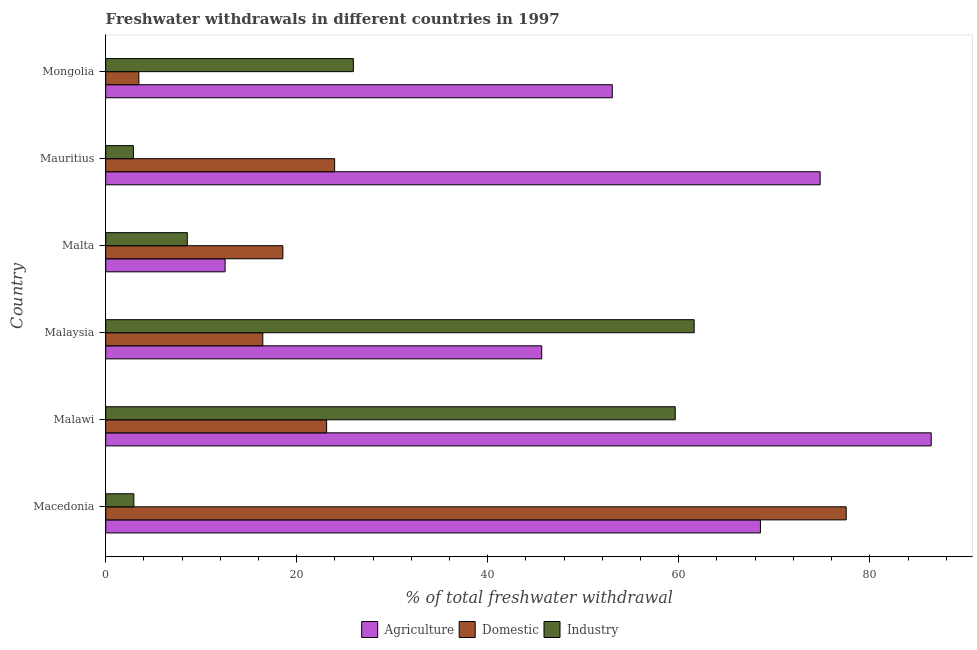Are the number of bars per tick equal to the number of legend labels?
Make the answer very short. Yes. Are the number of bars on each tick of the Y-axis equal?
Ensure brevity in your answer.  Yes. What is the label of the 3rd group of bars from the top?
Make the answer very short. Malta. In how many cases, is the number of bars for a given country not equal to the number of legend labels?
Give a very brief answer. 0. What is the percentage of freshwater withdrawal for agriculture in Mauritius?
Keep it short and to the point. 74.8. Across all countries, what is the maximum percentage of freshwater withdrawal for agriculture?
Offer a terse response. 86.43. Across all countries, what is the minimum percentage of freshwater withdrawal for domestic purposes?
Provide a succinct answer. 3.47. In which country was the percentage of freshwater withdrawal for agriculture maximum?
Offer a terse response. Malawi. In which country was the percentage of freshwater withdrawal for agriculture minimum?
Provide a short and direct response. Malta. What is the total percentage of freshwater withdrawal for domestic purposes in the graph?
Your answer should be compact. 163.1. What is the difference between the percentage of freshwater withdrawal for industry in Malta and that in Mongolia?
Offer a very short reply. -17.39. What is the difference between the percentage of freshwater withdrawal for agriculture in Malaysia and the percentage of freshwater withdrawal for industry in Mauritius?
Provide a short and direct response. 42.75. What is the average percentage of freshwater withdrawal for agriculture per country?
Ensure brevity in your answer.  56.83. What is the difference between the percentage of freshwater withdrawal for industry and percentage of freshwater withdrawal for agriculture in Mongolia?
Your response must be concise. -27.11. What is the ratio of the percentage of freshwater withdrawal for agriculture in Malawi to that in Malta?
Ensure brevity in your answer.  6.91. Is the percentage of freshwater withdrawal for domestic purposes in Malaysia less than that in Mauritius?
Offer a very short reply. Yes. What is the difference between the highest and the second highest percentage of freshwater withdrawal for agriculture?
Your response must be concise. 11.63. What is the difference between the highest and the lowest percentage of freshwater withdrawal for domestic purposes?
Provide a short and direct response. 74.06. In how many countries, is the percentage of freshwater withdrawal for industry greater than the average percentage of freshwater withdrawal for industry taken over all countries?
Give a very brief answer. 2. Is the sum of the percentage of freshwater withdrawal for agriculture in Macedonia and Mauritius greater than the maximum percentage of freshwater withdrawal for domestic purposes across all countries?
Ensure brevity in your answer.  Yes. What does the 1st bar from the top in Malaysia represents?
Provide a succinct answer. Industry. What does the 2nd bar from the bottom in Macedonia represents?
Provide a short and direct response. Domestic. How many bars are there?
Your answer should be very brief. 18. Are all the bars in the graph horizontal?
Your answer should be very brief. Yes. Are the values on the major ticks of X-axis written in scientific E-notation?
Give a very brief answer. No. Does the graph contain any zero values?
Your answer should be compact. No. Does the graph contain grids?
Provide a succinct answer. No. What is the title of the graph?
Your answer should be compact. Freshwater withdrawals in different countries in 1997. What is the label or title of the X-axis?
Ensure brevity in your answer.  % of total freshwater withdrawal. What is the label or title of the Y-axis?
Provide a succinct answer. Country. What is the % of total freshwater withdrawal in Agriculture in Macedonia?
Ensure brevity in your answer.  68.55. What is the % of total freshwater withdrawal in Domestic in Macedonia?
Give a very brief answer. 77.53. What is the % of total freshwater withdrawal in Industry in Macedonia?
Provide a succinct answer. 2.95. What is the % of total freshwater withdrawal in Agriculture in Malawi?
Your response must be concise. 86.43. What is the % of total freshwater withdrawal of Domestic in Malawi?
Ensure brevity in your answer.  23.13. What is the % of total freshwater withdrawal of Industry in Malawi?
Provide a short and direct response. 59.63. What is the % of total freshwater withdrawal of Agriculture in Malaysia?
Make the answer very short. 45.65. What is the % of total freshwater withdrawal in Domestic in Malaysia?
Your response must be concise. 16.45. What is the % of total freshwater withdrawal in Industry in Malaysia?
Ensure brevity in your answer.  61.61. What is the % of total freshwater withdrawal in Agriculture in Malta?
Your answer should be compact. 12.5. What is the % of total freshwater withdrawal in Domestic in Malta?
Keep it short and to the point. 18.55. What is the % of total freshwater withdrawal of Industry in Malta?
Your response must be concise. 8.54. What is the % of total freshwater withdrawal of Agriculture in Mauritius?
Offer a terse response. 74.8. What is the % of total freshwater withdrawal of Domestic in Mauritius?
Your answer should be very brief. 23.97. What is the % of total freshwater withdrawal of Industry in Mauritius?
Offer a terse response. 2.9. What is the % of total freshwater withdrawal of Agriculture in Mongolia?
Your answer should be very brief. 53.04. What is the % of total freshwater withdrawal in Domestic in Mongolia?
Offer a very short reply. 3.47. What is the % of total freshwater withdrawal of Industry in Mongolia?
Provide a succinct answer. 25.93. Across all countries, what is the maximum % of total freshwater withdrawal in Agriculture?
Your answer should be very brief. 86.43. Across all countries, what is the maximum % of total freshwater withdrawal in Domestic?
Give a very brief answer. 77.53. Across all countries, what is the maximum % of total freshwater withdrawal in Industry?
Give a very brief answer. 61.61. Across all countries, what is the minimum % of total freshwater withdrawal in Agriculture?
Offer a terse response. 12.5. Across all countries, what is the minimum % of total freshwater withdrawal of Domestic?
Keep it short and to the point. 3.47. Across all countries, what is the minimum % of total freshwater withdrawal of Industry?
Keep it short and to the point. 2.9. What is the total % of total freshwater withdrawal in Agriculture in the graph?
Give a very brief answer. 340.97. What is the total % of total freshwater withdrawal of Domestic in the graph?
Offer a very short reply. 163.1. What is the total % of total freshwater withdrawal in Industry in the graph?
Your answer should be compact. 161.56. What is the difference between the % of total freshwater withdrawal in Agriculture in Macedonia and that in Malawi?
Make the answer very short. -17.88. What is the difference between the % of total freshwater withdrawal in Domestic in Macedonia and that in Malawi?
Offer a very short reply. 54.4. What is the difference between the % of total freshwater withdrawal in Industry in Macedonia and that in Malawi?
Your response must be concise. -56.68. What is the difference between the % of total freshwater withdrawal in Agriculture in Macedonia and that in Malaysia?
Ensure brevity in your answer.  22.9. What is the difference between the % of total freshwater withdrawal of Domestic in Macedonia and that in Malaysia?
Provide a short and direct response. 61.08. What is the difference between the % of total freshwater withdrawal in Industry in Macedonia and that in Malaysia?
Provide a short and direct response. -58.66. What is the difference between the % of total freshwater withdrawal in Agriculture in Macedonia and that in Malta?
Offer a very short reply. 56.05. What is the difference between the % of total freshwater withdrawal of Domestic in Macedonia and that in Malta?
Give a very brief answer. 58.98. What is the difference between the % of total freshwater withdrawal of Industry in Macedonia and that in Malta?
Keep it short and to the point. -5.59. What is the difference between the % of total freshwater withdrawal of Agriculture in Macedonia and that in Mauritius?
Keep it short and to the point. -6.25. What is the difference between the % of total freshwater withdrawal in Domestic in Macedonia and that in Mauritius?
Ensure brevity in your answer.  53.56. What is the difference between the % of total freshwater withdrawal in Industry in Macedonia and that in Mauritius?
Ensure brevity in your answer.  0.05. What is the difference between the % of total freshwater withdrawal in Agriculture in Macedonia and that in Mongolia?
Your answer should be very brief. 15.51. What is the difference between the % of total freshwater withdrawal of Domestic in Macedonia and that in Mongolia?
Make the answer very short. 74.06. What is the difference between the % of total freshwater withdrawal in Industry in Macedonia and that in Mongolia?
Offer a very short reply. -22.98. What is the difference between the % of total freshwater withdrawal in Agriculture in Malawi and that in Malaysia?
Offer a very short reply. 40.78. What is the difference between the % of total freshwater withdrawal in Domestic in Malawi and that in Malaysia?
Provide a short and direct response. 6.68. What is the difference between the % of total freshwater withdrawal of Industry in Malawi and that in Malaysia?
Your answer should be very brief. -1.98. What is the difference between the % of total freshwater withdrawal of Agriculture in Malawi and that in Malta?
Offer a very short reply. 73.93. What is the difference between the % of total freshwater withdrawal of Domestic in Malawi and that in Malta?
Offer a terse response. 4.58. What is the difference between the % of total freshwater withdrawal in Industry in Malawi and that in Malta?
Provide a succinct answer. 51.09. What is the difference between the % of total freshwater withdrawal of Agriculture in Malawi and that in Mauritius?
Provide a succinct answer. 11.63. What is the difference between the % of total freshwater withdrawal in Domestic in Malawi and that in Mauritius?
Offer a very short reply. -0.84. What is the difference between the % of total freshwater withdrawal in Industry in Malawi and that in Mauritius?
Offer a terse response. 56.73. What is the difference between the % of total freshwater withdrawal in Agriculture in Malawi and that in Mongolia?
Provide a short and direct response. 33.39. What is the difference between the % of total freshwater withdrawal in Domestic in Malawi and that in Mongolia?
Your answer should be compact. 19.66. What is the difference between the % of total freshwater withdrawal in Industry in Malawi and that in Mongolia?
Your answer should be very brief. 33.7. What is the difference between the % of total freshwater withdrawal in Agriculture in Malaysia and that in Malta?
Your answer should be very brief. 33.15. What is the difference between the % of total freshwater withdrawal in Industry in Malaysia and that in Malta?
Offer a terse response. 53.07. What is the difference between the % of total freshwater withdrawal in Agriculture in Malaysia and that in Mauritius?
Your response must be concise. -29.15. What is the difference between the % of total freshwater withdrawal in Domestic in Malaysia and that in Mauritius?
Provide a succinct answer. -7.52. What is the difference between the % of total freshwater withdrawal in Industry in Malaysia and that in Mauritius?
Ensure brevity in your answer.  58.71. What is the difference between the % of total freshwater withdrawal in Agriculture in Malaysia and that in Mongolia?
Keep it short and to the point. -7.39. What is the difference between the % of total freshwater withdrawal of Domestic in Malaysia and that in Mongolia?
Offer a very short reply. 12.98. What is the difference between the % of total freshwater withdrawal of Industry in Malaysia and that in Mongolia?
Ensure brevity in your answer.  35.68. What is the difference between the % of total freshwater withdrawal of Agriculture in Malta and that in Mauritius?
Make the answer very short. -62.3. What is the difference between the % of total freshwater withdrawal of Domestic in Malta and that in Mauritius?
Provide a succinct answer. -5.42. What is the difference between the % of total freshwater withdrawal of Industry in Malta and that in Mauritius?
Provide a succinct answer. 5.65. What is the difference between the % of total freshwater withdrawal in Agriculture in Malta and that in Mongolia?
Make the answer very short. -40.54. What is the difference between the % of total freshwater withdrawal of Domestic in Malta and that in Mongolia?
Keep it short and to the point. 15.08. What is the difference between the % of total freshwater withdrawal in Industry in Malta and that in Mongolia?
Make the answer very short. -17.39. What is the difference between the % of total freshwater withdrawal in Agriculture in Mauritius and that in Mongolia?
Your answer should be very brief. 21.76. What is the difference between the % of total freshwater withdrawal in Domestic in Mauritius and that in Mongolia?
Offer a terse response. 20.5. What is the difference between the % of total freshwater withdrawal of Industry in Mauritius and that in Mongolia?
Your response must be concise. -23.03. What is the difference between the % of total freshwater withdrawal in Agriculture in Macedonia and the % of total freshwater withdrawal in Domestic in Malawi?
Make the answer very short. 45.42. What is the difference between the % of total freshwater withdrawal in Agriculture in Macedonia and the % of total freshwater withdrawal in Industry in Malawi?
Ensure brevity in your answer.  8.92. What is the difference between the % of total freshwater withdrawal of Agriculture in Macedonia and the % of total freshwater withdrawal of Domestic in Malaysia?
Your answer should be very brief. 52.1. What is the difference between the % of total freshwater withdrawal of Agriculture in Macedonia and the % of total freshwater withdrawal of Industry in Malaysia?
Offer a very short reply. 6.94. What is the difference between the % of total freshwater withdrawal of Domestic in Macedonia and the % of total freshwater withdrawal of Industry in Malaysia?
Offer a very short reply. 15.92. What is the difference between the % of total freshwater withdrawal in Agriculture in Macedonia and the % of total freshwater withdrawal in Industry in Malta?
Ensure brevity in your answer.  60.01. What is the difference between the % of total freshwater withdrawal in Domestic in Macedonia and the % of total freshwater withdrawal in Industry in Malta?
Make the answer very short. 68.99. What is the difference between the % of total freshwater withdrawal of Agriculture in Macedonia and the % of total freshwater withdrawal of Domestic in Mauritius?
Offer a very short reply. 44.58. What is the difference between the % of total freshwater withdrawal in Agriculture in Macedonia and the % of total freshwater withdrawal in Industry in Mauritius?
Keep it short and to the point. 65.65. What is the difference between the % of total freshwater withdrawal in Domestic in Macedonia and the % of total freshwater withdrawal in Industry in Mauritius?
Give a very brief answer. 74.63. What is the difference between the % of total freshwater withdrawal in Agriculture in Macedonia and the % of total freshwater withdrawal in Domestic in Mongolia?
Ensure brevity in your answer.  65.08. What is the difference between the % of total freshwater withdrawal of Agriculture in Macedonia and the % of total freshwater withdrawal of Industry in Mongolia?
Provide a short and direct response. 42.62. What is the difference between the % of total freshwater withdrawal of Domestic in Macedonia and the % of total freshwater withdrawal of Industry in Mongolia?
Offer a very short reply. 51.6. What is the difference between the % of total freshwater withdrawal in Agriculture in Malawi and the % of total freshwater withdrawal in Domestic in Malaysia?
Your answer should be very brief. 69.98. What is the difference between the % of total freshwater withdrawal in Agriculture in Malawi and the % of total freshwater withdrawal in Industry in Malaysia?
Provide a succinct answer. 24.82. What is the difference between the % of total freshwater withdrawal in Domestic in Malawi and the % of total freshwater withdrawal in Industry in Malaysia?
Offer a terse response. -38.48. What is the difference between the % of total freshwater withdrawal in Agriculture in Malawi and the % of total freshwater withdrawal in Domestic in Malta?
Offer a terse response. 67.88. What is the difference between the % of total freshwater withdrawal in Agriculture in Malawi and the % of total freshwater withdrawal in Industry in Malta?
Offer a very short reply. 77.89. What is the difference between the % of total freshwater withdrawal of Domestic in Malawi and the % of total freshwater withdrawal of Industry in Malta?
Offer a very short reply. 14.59. What is the difference between the % of total freshwater withdrawal of Agriculture in Malawi and the % of total freshwater withdrawal of Domestic in Mauritius?
Offer a terse response. 62.46. What is the difference between the % of total freshwater withdrawal in Agriculture in Malawi and the % of total freshwater withdrawal in Industry in Mauritius?
Offer a terse response. 83.53. What is the difference between the % of total freshwater withdrawal in Domestic in Malawi and the % of total freshwater withdrawal in Industry in Mauritius?
Your answer should be very brief. 20.23. What is the difference between the % of total freshwater withdrawal of Agriculture in Malawi and the % of total freshwater withdrawal of Domestic in Mongolia?
Ensure brevity in your answer.  82.96. What is the difference between the % of total freshwater withdrawal in Agriculture in Malawi and the % of total freshwater withdrawal in Industry in Mongolia?
Give a very brief answer. 60.5. What is the difference between the % of total freshwater withdrawal of Agriculture in Malaysia and the % of total freshwater withdrawal of Domestic in Malta?
Provide a succinct answer. 27.1. What is the difference between the % of total freshwater withdrawal in Agriculture in Malaysia and the % of total freshwater withdrawal in Industry in Malta?
Give a very brief answer. 37.11. What is the difference between the % of total freshwater withdrawal of Domestic in Malaysia and the % of total freshwater withdrawal of Industry in Malta?
Your response must be concise. 7.91. What is the difference between the % of total freshwater withdrawal in Agriculture in Malaysia and the % of total freshwater withdrawal in Domestic in Mauritius?
Offer a terse response. 21.68. What is the difference between the % of total freshwater withdrawal of Agriculture in Malaysia and the % of total freshwater withdrawal of Industry in Mauritius?
Make the answer very short. 42.75. What is the difference between the % of total freshwater withdrawal of Domestic in Malaysia and the % of total freshwater withdrawal of Industry in Mauritius?
Keep it short and to the point. 13.55. What is the difference between the % of total freshwater withdrawal in Agriculture in Malaysia and the % of total freshwater withdrawal in Domestic in Mongolia?
Give a very brief answer. 42.18. What is the difference between the % of total freshwater withdrawal of Agriculture in Malaysia and the % of total freshwater withdrawal of Industry in Mongolia?
Provide a short and direct response. 19.72. What is the difference between the % of total freshwater withdrawal in Domestic in Malaysia and the % of total freshwater withdrawal in Industry in Mongolia?
Give a very brief answer. -9.48. What is the difference between the % of total freshwater withdrawal in Agriculture in Malta and the % of total freshwater withdrawal in Domestic in Mauritius?
Give a very brief answer. -11.47. What is the difference between the % of total freshwater withdrawal of Agriculture in Malta and the % of total freshwater withdrawal of Industry in Mauritius?
Your answer should be compact. 9.6. What is the difference between the % of total freshwater withdrawal in Domestic in Malta and the % of total freshwater withdrawal in Industry in Mauritius?
Your response must be concise. 15.65. What is the difference between the % of total freshwater withdrawal of Agriculture in Malta and the % of total freshwater withdrawal of Domestic in Mongolia?
Give a very brief answer. 9.03. What is the difference between the % of total freshwater withdrawal of Agriculture in Malta and the % of total freshwater withdrawal of Industry in Mongolia?
Give a very brief answer. -13.43. What is the difference between the % of total freshwater withdrawal in Domestic in Malta and the % of total freshwater withdrawal in Industry in Mongolia?
Your response must be concise. -7.38. What is the difference between the % of total freshwater withdrawal of Agriculture in Mauritius and the % of total freshwater withdrawal of Domestic in Mongolia?
Ensure brevity in your answer.  71.33. What is the difference between the % of total freshwater withdrawal in Agriculture in Mauritius and the % of total freshwater withdrawal in Industry in Mongolia?
Offer a terse response. 48.87. What is the difference between the % of total freshwater withdrawal in Domestic in Mauritius and the % of total freshwater withdrawal in Industry in Mongolia?
Keep it short and to the point. -1.96. What is the average % of total freshwater withdrawal of Agriculture per country?
Offer a terse response. 56.83. What is the average % of total freshwater withdrawal of Domestic per country?
Your answer should be compact. 27.18. What is the average % of total freshwater withdrawal in Industry per country?
Your answer should be compact. 26.93. What is the difference between the % of total freshwater withdrawal in Agriculture and % of total freshwater withdrawal in Domestic in Macedonia?
Your answer should be very brief. -8.98. What is the difference between the % of total freshwater withdrawal in Agriculture and % of total freshwater withdrawal in Industry in Macedonia?
Offer a very short reply. 65.6. What is the difference between the % of total freshwater withdrawal of Domestic and % of total freshwater withdrawal of Industry in Macedonia?
Offer a terse response. 74.58. What is the difference between the % of total freshwater withdrawal in Agriculture and % of total freshwater withdrawal in Domestic in Malawi?
Give a very brief answer. 63.3. What is the difference between the % of total freshwater withdrawal of Agriculture and % of total freshwater withdrawal of Industry in Malawi?
Keep it short and to the point. 26.8. What is the difference between the % of total freshwater withdrawal of Domestic and % of total freshwater withdrawal of Industry in Malawi?
Keep it short and to the point. -36.5. What is the difference between the % of total freshwater withdrawal in Agriculture and % of total freshwater withdrawal in Domestic in Malaysia?
Ensure brevity in your answer.  29.2. What is the difference between the % of total freshwater withdrawal of Agriculture and % of total freshwater withdrawal of Industry in Malaysia?
Ensure brevity in your answer.  -15.96. What is the difference between the % of total freshwater withdrawal in Domestic and % of total freshwater withdrawal in Industry in Malaysia?
Your answer should be compact. -45.16. What is the difference between the % of total freshwater withdrawal in Agriculture and % of total freshwater withdrawal in Domestic in Malta?
Make the answer very short. -6.05. What is the difference between the % of total freshwater withdrawal in Agriculture and % of total freshwater withdrawal in Industry in Malta?
Keep it short and to the point. 3.96. What is the difference between the % of total freshwater withdrawal in Domestic and % of total freshwater withdrawal in Industry in Malta?
Ensure brevity in your answer.  10.01. What is the difference between the % of total freshwater withdrawal in Agriculture and % of total freshwater withdrawal in Domestic in Mauritius?
Provide a succinct answer. 50.83. What is the difference between the % of total freshwater withdrawal in Agriculture and % of total freshwater withdrawal in Industry in Mauritius?
Your response must be concise. 71.9. What is the difference between the % of total freshwater withdrawal of Domestic and % of total freshwater withdrawal of Industry in Mauritius?
Your answer should be very brief. 21.07. What is the difference between the % of total freshwater withdrawal in Agriculture and % of total freshwater withdrawal in Domestic in Mongolia?
Keep it short and to the point. 49.57. What is the difference between the % of total freshwater withdrawal in Agriculture and % of total freshwater withdrawal in Industry in Mongolia?
Your response must be concise. 27.11. What is the difference between the % of total freshwater withdrawal in Domestic and % of total freshwater withdrawal in Industry in Mongolia?
Provide a short and direct response. -22.46. What is the ratio of the % of total freshwater withdrawal of Agriculture in Macedonia to that in Malawi?
Make the answer very short. 0.79. What is the ratio of the % of total freshwater withdrawal of Domestic in Macedonia to that in Malawi?
Give a very brief answer. 3.35. What is the ratio of the % of total freshwater withdrawal of Industry in Macedonia to that in Malawi?
Ensure brevity in your answer.  0.05. What is the ratio of the % of total freshwater withdrawal of Agriculture in Macedonia to that in Malaysia?
Your response must be concise. 1.5. What is the ratio of the % of total freshwater withdrawal of Domestic in Macedonia to that in Malaysia?
Offer a terse response. 4.71. What is the ratio of the % of total freshwater withdrawal in Industry in Macedonia to that in Malaysia?
Your response must be concise. 0.05. What is the ratio of the % of total freshwater withdrawal in Agriculture in Macedonia to that in Malta?
Provide a short and direct response. 5.48. What is the ratio of the % of total freshwater withdrawal in Domestic in Macedonia to that in Malta?
Your answer should be compact. 4.18. What is the ratio of the % of total freshwater withdrawal of Industry in Macedonia to that in Malta?
Your answer should be compact. 0.35. What is the ratio of the % of total freshwater withdrawal in Agriculture in Macedonia to that in Mauritius?
Your answer should be very brief. 0.92. What is the ratio of the % of total freshwater withdrawal in Domestic in Macedonia to that in Mauritius?
Provide a short and direct response. 3.23. What is the ratio of the % of total freshwater withdrawal in Industry in Macedonia to that in Mauritius?
Provide a short and direct response. 1.02. What is the ratio of the % of total freshwater withdrawal in Agriculture in Macedonia to that in Mongolia?
Your answer should be compact. 1.29. What is the ratio of the % of total freshwater withdrawal in Domestic in Macedonia to that in Mongolia?
Ensure brevity in your answer.  22.34. What is the ratio of the % of total freshwater withdrawal of Industry in Macedonia to that in Mongolia?
Your answer should be very brief. 0.11. What is the ratio of the % of total freshwater withdrawal of Agriculture in Malawi to that in Malaysia?
Ensure brevity in your answer.  1.89. What is the ratio of the % of total freshwater withdrawal of Domestic in Malawi to that in Malaysia?
Your response must be concise. 1.41. What is the ratio of the % of total freshwater withdrawal of Industry in Malawi to that in Malaysia?
Your response must be concise. 0.97. What is the ratio of the % of total freshwater withdrawal in Agriculture in Malawi to that in Malta?
Provide a short and direct response. 6.91. What is the ratio of the % of total freshwater withdrawal of Domestic in Malawi to that in Malta?
Offer a terse response. 1.25. What is the ratio of the % of total freshwater withdrawal in Industry in Malawi to that in Malta?
Your answer should be very brief. 6.98. What is the ratio of the % of total freshwater withdrawal in Agriculture in Malawi to that in Mauritius?
Keep it short and to the point. 1.16. What is the ratio of the % of total freshwater withdrawal in Domestic in Malawi to that in Mauritius?
Provide a short and direct response. 0.96. What is the ratio of the % of total freshwater withdrawal in Industry in Malawi to that in Mauritius?
Ensure brevity in your answer.  20.58. What is the ratio of the % of total freshwater withdrawal of Agriculture in Malawi to that in Mongolia?
Your answer should be compact. 1.63. What is the ratio of the % of total freshwater withdrawal in Domestic in Malawi to that in Mongolia?
Ensure brevity in your answer.  6.66. What is the ratio of the % of total freshwater withdrawal in Industry in Malawi to that in Mongolia?
Provide a short and direct response. 2.3. What is the ratio of the % of total freshwater withdrawal of Agriculture in Malaysia to that in Malta?
Make the answer very short. 3.65. What is the ratio of the % of total freshwater withdrawal in Domestic in Malaysia to that in Malta?
Give a very brief answer. 0.89. What is the ratio of the % of total freshwater withdrawal of Industry in Malaysia to that in Malta?
Your answer should be very brief. 7.21. What is the ratio of the % of total freshwater withdrawal of Agriculture in Malaysia to that in Mauritius?
Offer a terse response. 0.61. What is the ratio of the % of total freshwater withdrawal of Domestic in Malaysia to that in Mauritius?
Keep it short and to the point. 0.69. What is the ratio of the % of total freshwater withdrawal in Industry in Malaysia to that in Mauritius?
Provide a short and direct response. 21.27. What is the ratio of the % of total freshwater withdrawal in Agriculture in Malaysia to that in Mongolia?
Give a very brief answer. 0.86. What is the ratio of the % of total freshwater withdrawal of Domestic in Malaysia to that in Mongolia?
Provide a short and direct response. 4.74. What is the ratio of the % of total freshwater withdrawal of Industry in Malaysia to that in Mongolia?
Provide a succinct answer. 2.38. What is the ratio of the % of total freshwater withdrawal of Agriculture in Malta to that in Mauritius?
Provide a short and direct response. 0.17. What is the ratio of the % of total freshwater withdrawal of Domestic in Malta to that in Mauritius?
Offer a terse response. 0.77. What is the ratio of the % of total freshwater withdrawal of Industry in Malta to that in Mauritius?
Your answer should be compact. 2.95. What is the ratio of the % of total freshwater withdrawal in Agriculture in Malta to that in Mongolia?
Give a very brief answer. 0.24. What is the ratio of the % of total freshwater withdrawal of Domestic in Malta to that in Mongolia?
Provide a succinct answer. 5.34. What is the ratio of the % of total freshwater withdrawal of Industry in Malta to that in Mongolia?
Your answer should be compact. 0.33. What is the ratio of the % of total freshwater withdrawal in Agriculture in Mauritius to that in Mongolia?
Provide a succinct answer. 1.41. What is the ratio of the % of total freshwater withdrawal in Domestic in Mauritius to that in Mongolia?
Provide a succinct answer. 6.91. What is the ratio of the % of total freshwater withdrawal of Industry in Mauritius to that in Mongolia?
Make the answer very short. 0.11. What is the difference between the highest and the second highest % of total freshwater withdrawal of Agriculture?
Ensure brevity in your answer.  11.63. What is the difference between the highest and the second highest % of total freshwater withdrawal of Domestic?
Your answer should be compact. 53.56. What is the difference between the highest and the second highest % of total freshwater withdrawal in Industry?
Offer a terse response. 1.98. What is the difference between the highest and the lowest % of total freshwater withdrawal in Agriculture?
Give a very brief answer. 73.93. What is the difference between the highest and the lowest % of total freshwater withdrawal in Domestic?
Your answer should be very brief. 74.06. What is the difference between the highest and the lowest % of total freshwater withdrawal in Industry?
Provide a short and direct response. 58.71. 